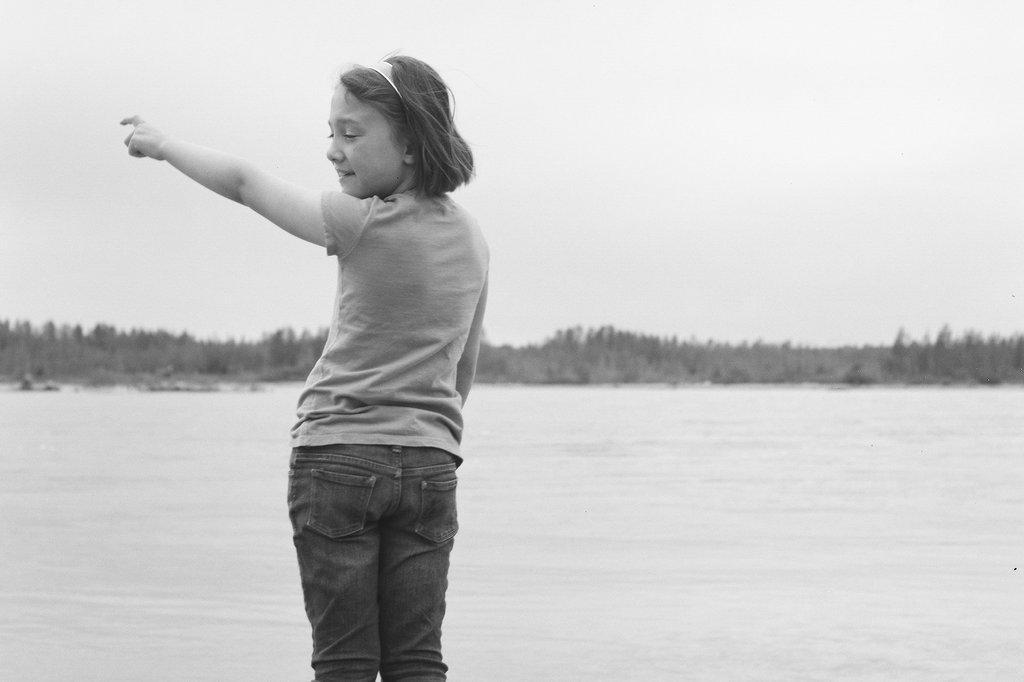Can you describe this image briefly? This is a black and white image. In the center of the image there is a girl. In the background of the image there are trees. There is water. 